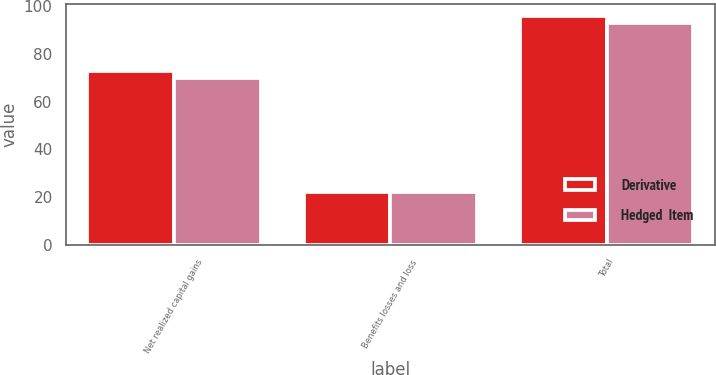Convert chart to OTSL. <chart><loc_0><loc_0><loc_500><loc_500><stacked_bar_chart><ecel><fcel>Net realized capital gains<fcel>Benefits losses and loss<fcel>Total<nl><fcel>Derivative<fcel>73<fcel>22<fcel>96<nl><fcel>Hedged  Item<fcel>70<fcel>22<fcel>93<nl></chart> 